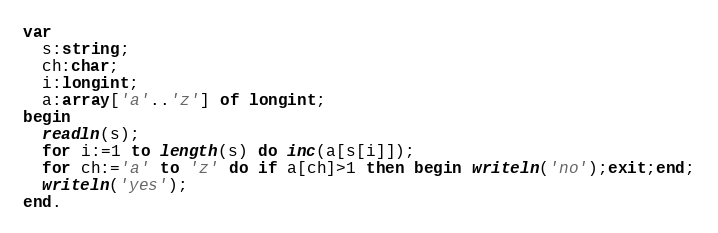<code> <loc_0><loc_0><loc_500><loc_500><_Pascal_>var
  s:string;
  ch:char;
  i:longint;
  a:array['a'..'z'] of longint;
begin
  readln(s);
  for i:=1 to length(s) do inc(a[s[i]]);
  for ch:='a' to 'z' do if a[ch]>1 then begin writeln('no');exit;end;
  writeln('yes');
end.</code> 